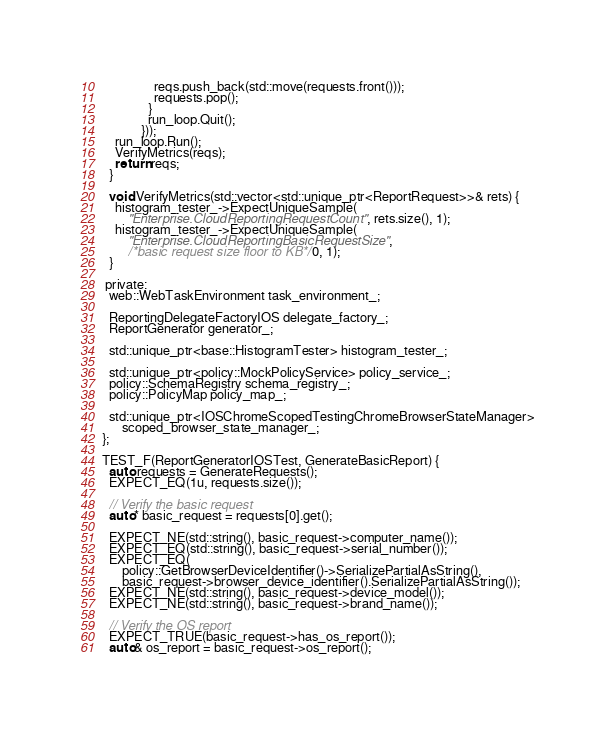Convert code to text. <code><loc_0><loc_0><loc_500><loc_500><_ObjectiveC_>                reqs.push_back(std::move(requests.front()));
                requests.pop();
              }
              run_loop.Quit();
            }));
    run_loop.Run();
    VerifyMetrics(reqs);
    return reqs;
  }

  void VerifyMetrics(std::vector<std::unique_ptr<ReportRequest>>& rets) {
    histogram_tester_->ExpectUniqueSample(
        "Enterprise.CloudReportingRequestCount", rets.size(), 1);
    histogram_tester_->ExpectUniqueSample(
        "Enterprise.CloudReportingBasicRequestSize",
        /*basic request size floor to KB*/ 0, 1);
  }

 private:
  web::WebTaskEnvironment task_environment_;

  ReportingDelegateFactoryIOS delegate_factory_;
  ReportGenerator generator_;

  std::unique_ptr<base::HistogramTester> histogram_tester_;

  std::unique_ptr<policy::MockPolicyService> policy_service_;
  policy::SchemaRegistry schema_registry_;
  policy::PolicyMap policy_map_;

  std::unique_ptr<IOSChromeScopedTestingChromeBrowserStateManager>
      scoped_browser_state_manager_;
};

TEST_F(ReportGeneratorIOSTest, GenerateBasicReport) {
  auto requests = GenerateRequests();
  EXPECT_EQ(1u, requests.size());

  // Verify the basic request
  auto* basic_request = requests[0].get();

  EXPECT_NE(std::string(), basic_request->computer_name());
  EXPECT_EQ(std::string(), basic_request->serial_number());
  EXPECT_EQ(
      policy::GetBrowserDeviceIdentifier()->SerializePartialAsString(),
      basic_request->browser_device_identifier().SerializePartialAsString());
  EXPECT_NE(std::string(), basic_request->device_model());
  EXPECT_NE(std::string(), basic_request->brand_name());

  // Verify the OS report
  EXPECT_TRUE(basic_request->has_os_report());
  auto& os_report = basic_request->os_report();</code> 